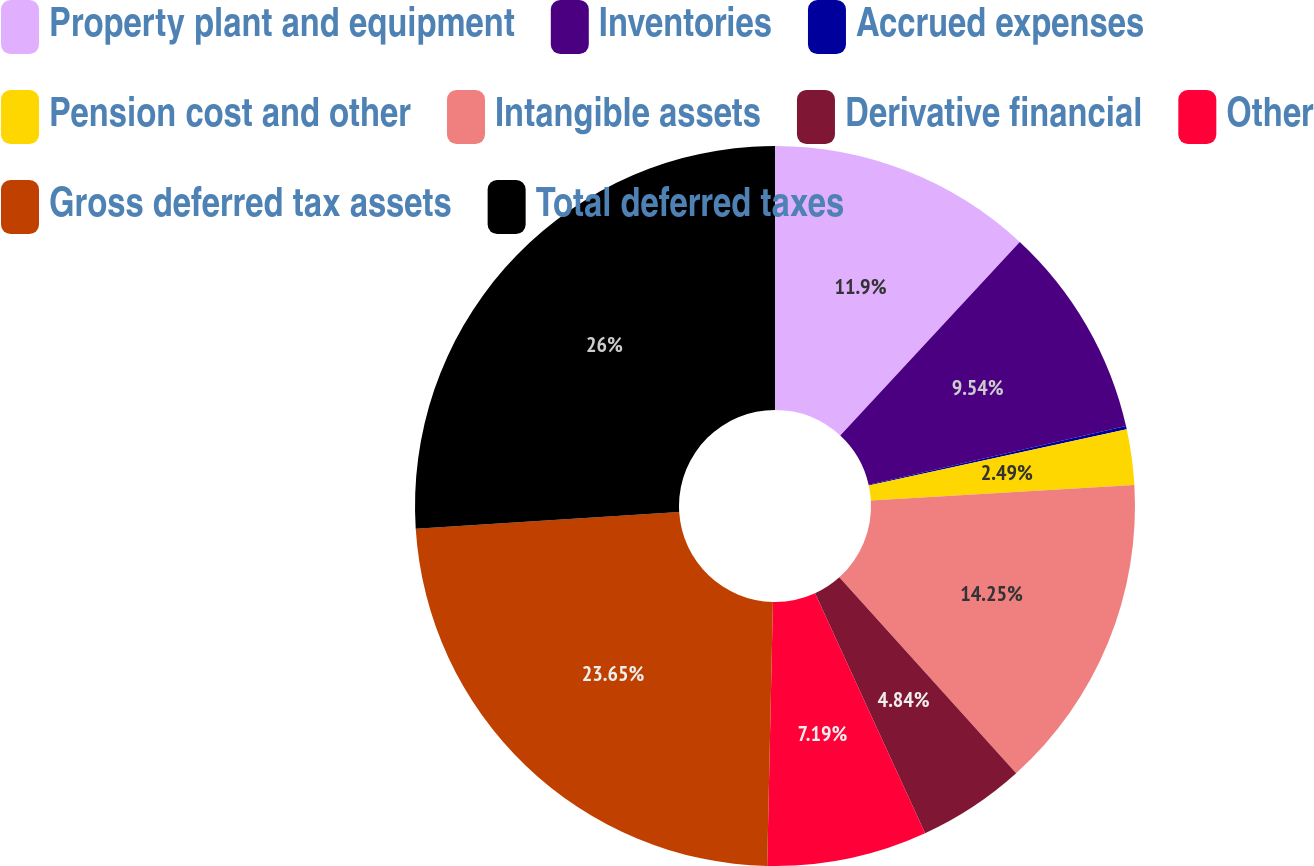Convert chart. <chart><loc_0><loc_0><loc_500><loc_500><pie_chart><fcel>Property plant and equipment<fcel>Inventories<fcel>Accrued expenses<fcel>Pension cost and other<fcel>Intangible assets<fcel>Derivative financial<fcel>Other<fcel>Gross deferred tax assets<fcel>Total deferred taxes<nl><fcel>11.9%<fcel>9.54%<fcel>0.14%<fcel>2.49%<fcel>14.25%<fcel>4.84%<fcel>7.19%<fcel>23.65%<fcel>26.01%<nl></chart> 